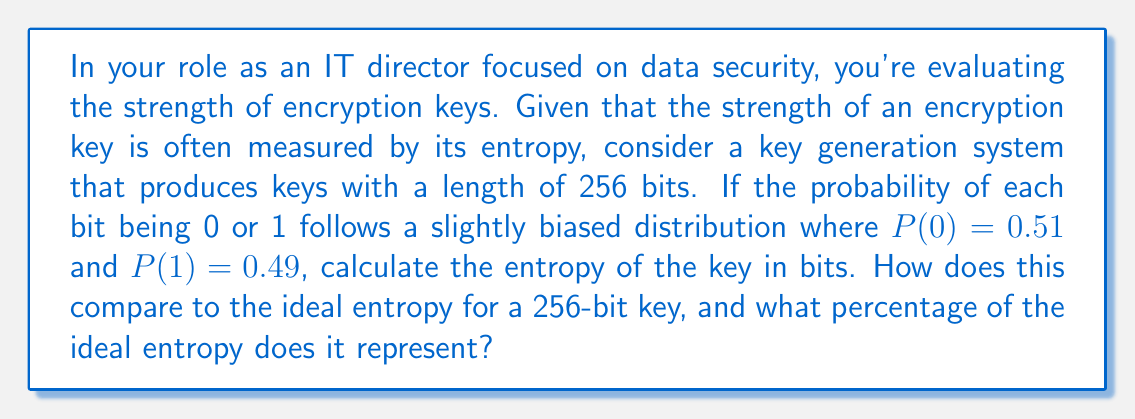Solve this math problem. To solve this problem, we'll use the concept of Shannon entropy from information theory, which is directly applicable to encryption key strength analysis.

1) The Shannon entropy formula for a binary system is:
   $$H = -\sum_{i=1}^n p_i \log_2(p_i)$$
   where $p_i$ is the probability of each outcome.

2) In our case:
   $$H = -(0.51 \log_2(0.51) + 0.49 \log_2(0.49))$$

3) Calculating:
   $$H = -(0.51 * (-0.9709) + 0.49 * (-1.0297))$$
   $$H = 0.4952 + 0.5046 = 0.9998$$ bits per bit

4) For a 256-bit key, the total entropy is:
   $$256 * 0.9998 = 255.9488$$ bits

5) The ideal entropy for a 256-bit key (with equal probabilities) would be 256 bits.

6) To calculate the percentage of ideal entropy:
   $$\frac{255.9488}{256} * 100\% = 99.98\%$$

Therefore, despite the slight bias in the bit distribution, the key still retains 99.98% of its ideal entropy.
Answer: The entropy of the 256-bit key is 255.9488 bits, which is 99.98% of the ideal entropy for a 256-bit key. 